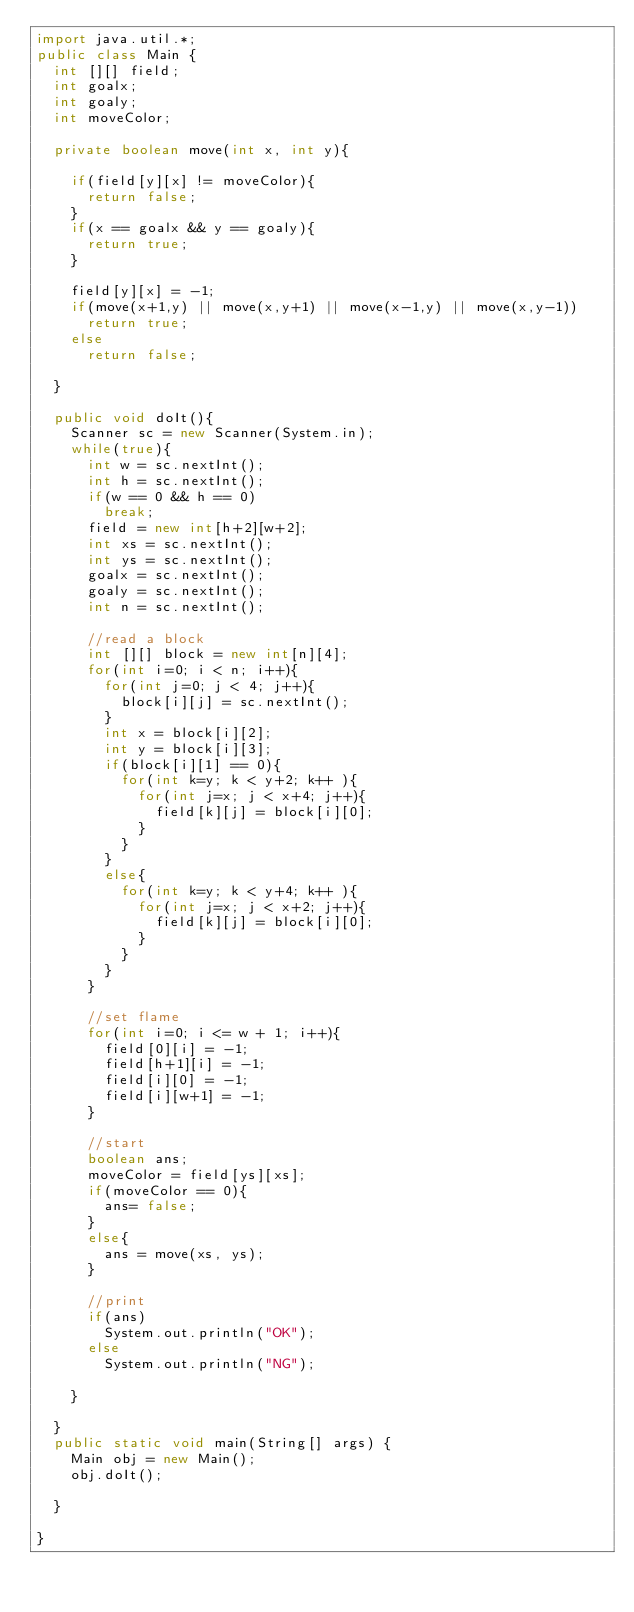<code> <loc_0><loc_0><loc_500><loc_500><_Java_>import java.util.*;
public class Main {
	int [][] field;
	int goalx;
	int goaly;
	int moveColor;

	private boolean move(int x, int y){

		if(field[y][x] != moveColor){
			return false;
		}
		if(x == goalx && y == goaly){
			return true;
		}

		field[y][x] = -1;
		if(move(x+1,y) || move(x,y+1) || move(x-1,y) || move(x,y-1))
			return true;
		else
			return false;

	}

	public void doIt(){
		Scanner sc = new Scanner(System.in);
		while(true){
			int w = sc.nextInt();
			int h = sc.nextInt();
			if(w == 0 && h == 0)
				break;
			field = new int[h+2][w+2];
			int xs = sc.nextInt();
			int ys = sc.nextInt();
			goalx = sc.nextInt();
			goaly = sc.nextInt();
			int n = sc.nextInt();

			//read a block
			int [][] block = new int[n][4];
			for(int i=0; i < n; i++){
				for(int j=0; j < 4; j++){
					block[i][j] = sc.nextInt();
				}
				int x = block[i][2];
				int y = block[i][3];
				if(block[i][1] == 0){
					for(int k=y; k < y+2; k++ ){
						for(int j=x; j < x+4; j++){
							field[k][j] = block[i][0];
						}
					}
				}
				else{
					for(int k=y; k < y+4; k++ ){
						for(int j=x; j < x+2; j++){
							field[k][j] = block[i][0];
						}
					}
				}
			}

			//set flame
			for(int i=0; i <= w + 1; i++){
				field[0][i] = -1;
				field[h+1][i] = -1;
				field[i][0] = -1;
				field[i][w+1] = -1;
			}

			//start
			boolean ans;
			moveColor = field[ys][xs];
			if(moveColor == 0){
				ans= false;
			}
			else{
				ans = move(xs, ys);
			}

			//print
			if(ans)
				System.out.println("OK");
			else
				System.out.println("NG");

		}

	}
	public static void main(String[] args) {
		Main obj = new Main();
		obj.doIt();

	}

}</code> 